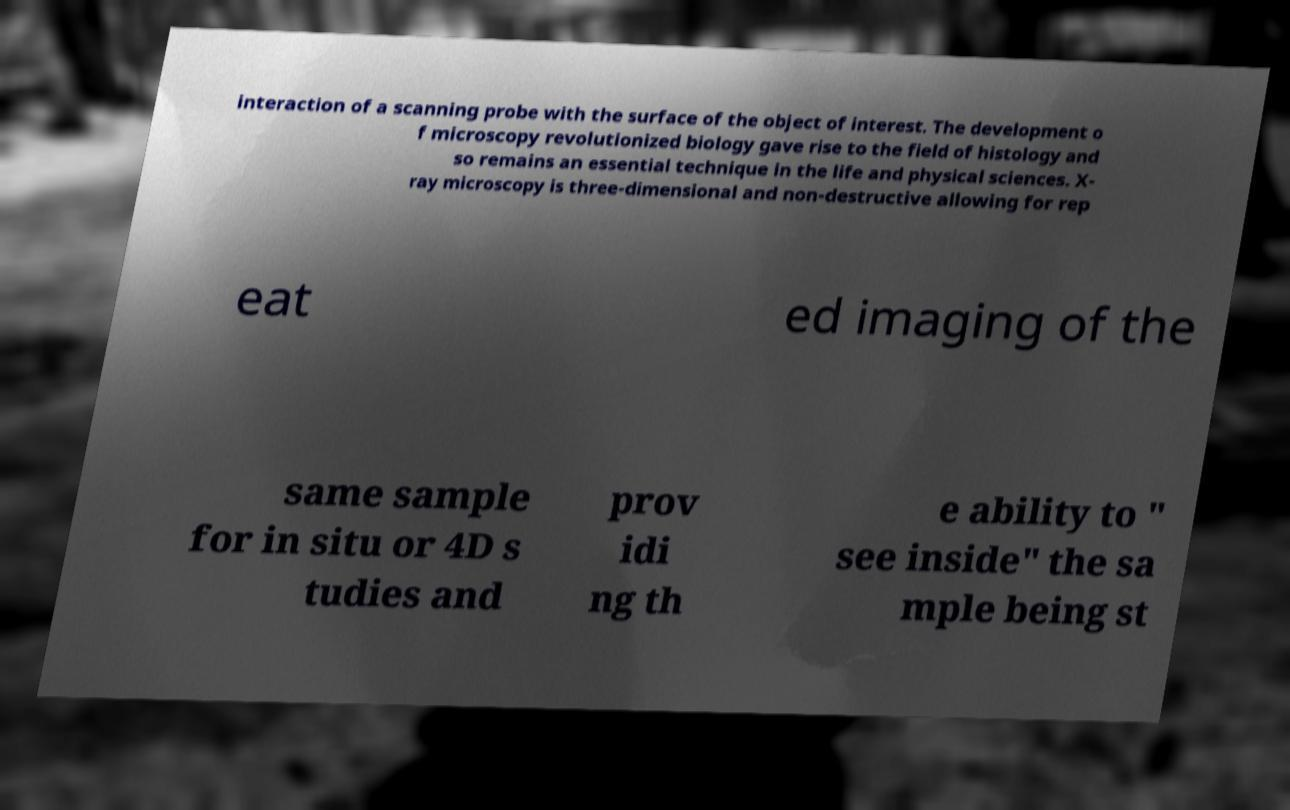For documentation purposes, I need the text within this image transcribed. Could you provide that? interaction of a scanning probe with the surface of the object of interest. The development o f microscopy revolutionized biology gave rise to the field of histology and so remains an essential technique in the life and physical sciences. X- ray microscopy is three-dimensional and non-destructive allowing for rep eat ed imaging of the same sample for in situ or 4D s tudies and prov idi ng th e ability to " see inside" the sa mple being st 